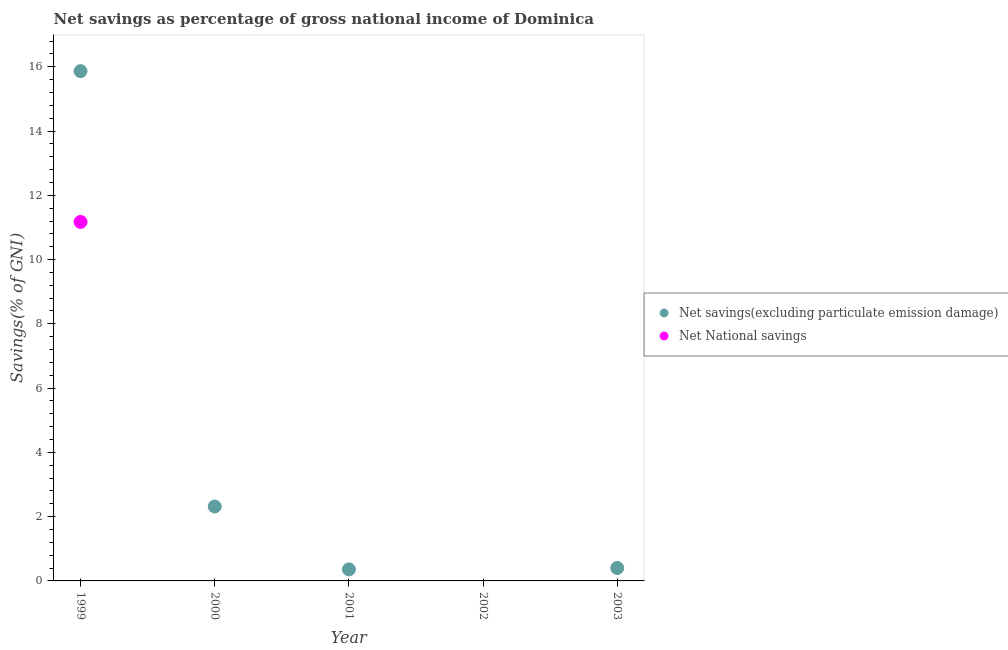Is the number of dotlines equal to the number of legend labels?
Provide a succinct answer. No. What is the net national savings in 2003?
Your answer should be compact. 0. Across all years, what is the maximum net savings(excluding particulate emission damage)?
Ensure brevity in your answer.  15.86. In which year was the net national savings maximum?
Keep it short and to the point. 1999. What is the total net savings(excluding particulate emission damage) in the graph?
Provide a short and direct response. 18.94. What is the difference between the net savings(excluding particulate emission damage) in 2000 and that in 2001?
Provide a short and direct response. 1.96. What is the difference between the net national savings in 1999 and the net savings(excluding particulate emission damage) in 2002?
Offer a terse response. 11.17. What is the average net savings(excluding particulate emission damage) per year?
Offer a terse response. 3.79. In the year 1999, what is the difference between the net national savings and net savings(excluding particulate emission damage)?
Offer a terse response. -4.69. What is the ratio of the net savings(excluding particulate emission damage) in 2000 to that in 2001?
Provide a succinct answer. 6.46. What is the difference between the highest and the second highest net savings(excluding particulate emission damage)?
Your answer should be very brief. 13.55. What is the difference between the highest and the lowest net national savings?
Keep it short and to the point. 11.17. Is the net national savings strictly greater than the net savings(excluding particulate emission damage) over the years?
Offer a terse response. No. How many dotlines are there?
Your answer should be compact. 2. How many years are there in the graph?
Provide a short and direct response. 5. Are the values on the major ticks of Y-axis written in scientific E-notation?
Offer a terse response. No. Does the graph contain any zero values?
Provide a short and direct response. Yes. What is the title of the graph?
Make the answer very short. Net savings as percentage of gross national income of Dominica. What is the label or title of the Y-axis?
Your answer should be compact. Savings(% of GNI). What is the Savings(% of GNI) in Net savings(excluding particulate emission damage) in 1999?
Your answer should be very brief. 15.86. What is the Savings(% of GNI) of Net National savings in 1999?
Provide a short and direct response. 11.17. What is the Savings(% of GNI) in Net savings(excluding particulate emission damage) in 2000?
Provide a short and direct response. 2.32. What is the Savings(% of GNI) of Net National savings in 2000?
Provide a succinct answer. 0. What is the Savings(% of GNI) in Net savings(excluding particulate emission damage) in 2001?
Ensure brevity in your answer.  0.36. What is the Savings(% of GNI) of Net National savings in 2002?
Your answer should be compact. 0. What is the Savings(% of GNI) of Net savings(excluding particulate emission damage) in 2003?
Ensure brevity in your answer.  0.4. What is the Savings(% of GNI) of Net National savings in 2003?
Provide a succinct answer. 0. Across all years, what is the maximum Savings(% of GNI) in Net savings(excluding particulate emission damage)?
Ensure brevity in your answer.  15.86. Across all years, what is the maximum Savings(% of GNI) of Net National savings?
Provide a short and direct response. 11.17. What is the total Savings(% of GNI) of Net savings(excluding particulate emission damage) in the graph?
Provide a succinct answer. 18.94. What is the total Savings(% of GNI) of Net National savings in the graph?
Offer a terse response. 11.17. What is the difference between the Savings(% of GNI) in Net savings(excluding particulate emission damage) in 1999 and that in 2000?
Provide a short and direct response. 13.55. What is the difference between the Savings(% of GNI) of Net savings(excluding particulate emission damage) in 1999 and that in 2001?
Ensure brevity in your answer.  15.51. What is the difference between the Savings(% of GNI) in Net savings(excluding particulate emission damage) in 1999 and that in 2003?
Your answer should be very brief. 15.46. What is the difference between the Savings(% of GNI) in Net savings(excluding particulate emission damage) in 2000 and that in 2001?
Ensure brevity in your answer.  1.96. What is the difference between the Savings(% of GNI) of Net savings(excluding particulate emission damage) in 2000 and that in 2003?
Ensure brevity in your answer.  1.91. What is the difference between the Savings(% of GNI) of Net savings(excluding particulate emission damage) in 2001 and that in 2003?
Provide a succinct answer. -0.04. What is the average Savings(% of GNI) in Net savings(excluding particulate emission damage) per year?
Provide a succinct answer. 3.79. What is the average Savings(% of GNI) in Net National savings per year?
Provide a short and direct response. 2.23. In the year 1999, what is the difference between the Savings(% of GNI) of Net savings(excluding particulate emission damage) and Savings(% of GNI) of Net National savings?
Provide a succinct answer. 4.69. What is the ratio of the Savings(% of GNI) of Net savings(excluding particulate emission damage) in 1999 to that in 2000?
Give a very brief answer. 6.85. What is the ratio of the Savings(% of GNI) of Net savings(excluding particulate emission damage) in 1999 to that in 2001?
Make the answer very short. 44.25. What is the ratio of the Savings(% of GNI) of Net savings(excluding particulate emission damage) in 1999 to that in 2003?
Offer a very short reply. 39.36. What is the ratio of the Savings(% of GNI) of Net savings(excluding particulate emission damage) in 2000 to that in 2001?
Give a very brief answer. 6.46. What is the ratio of the Savings(% of GNI) of Net savings(excluding particulate emission damage) in 2000 to that in 2003?
Keep it short and to the point. 5.74. What is the ratio of the Savings(% of GNI) in Net savings(excluding particulate emission damage) in 2001 to that in 2003?
Your answer should be very brief. 0.89. What is the difference between the highest and the second highest Savings(% of GNI) in Net savings(excluding particulate emission damage)?
Keep it short and to the point. 13.55. What is the difference between the highest and the lowest Savings(% of GNI) of Net savings(excluding particulate emission damage)?
Give a very brief answer. 15.86. What is the difference between the highest and the lowest Savings(% of GNI) of Net National savings?
Offer a terse response. 11.17. 